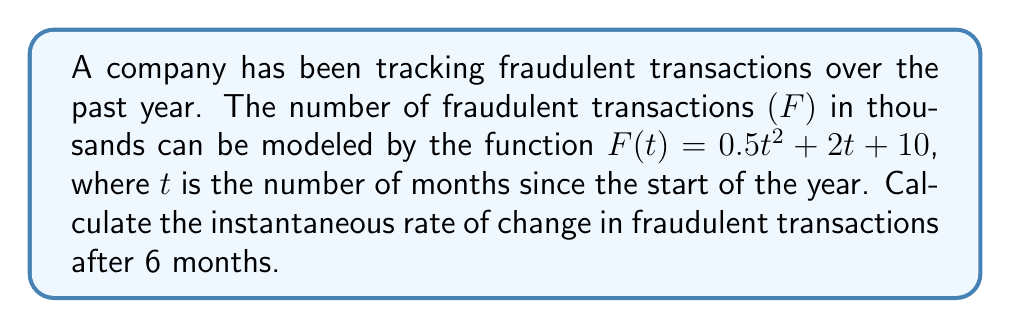Can you solve this math problem? To find the instantaneous rate of change, we need to calculate the derivative of the function $F(t)$ and evaluate it at $t = 6$.

Step 1: Find the derivative of $F(t)$.
$F(t) = 0.5t^2 + 2t + 10$
$F'(t) = \frac{d}{dt}(0.5t^2 + 2t + 10)$
$F'(t) = 1t + 2$

Step 2: Evaluate $F'(t)$ at $t = 6$.
$F'(6) = 1(6) + 2 = 8$

The instantaneous rate of change after 6 months is 8 thousand fraudulent transactions per month.
Answer: 8 thousand fraudulent transactions per month 